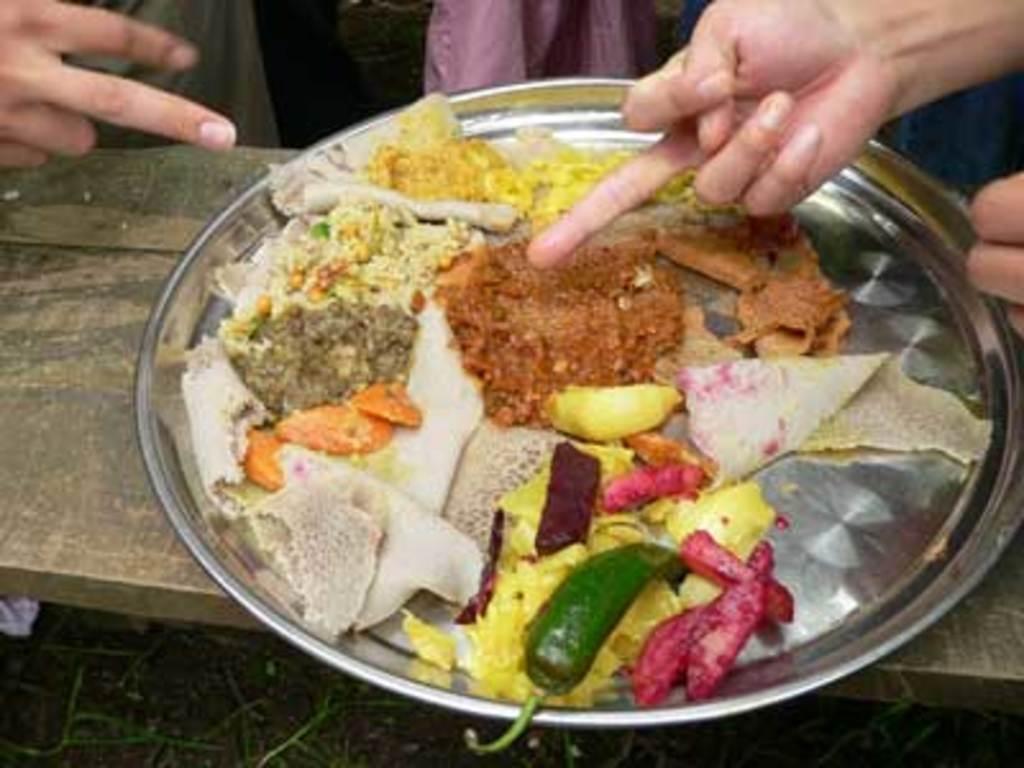Describe this image in one or two sentences. In this image we can see some food items on the plate and the plate is on the table, there we can see few persons hands and legs, there we we can also see some grass under the table. 